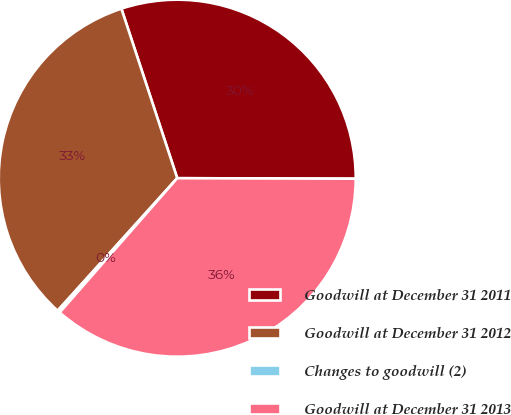Convert chart to OTSL. <chart><loc_0><loc_0><loc_500><loc_500><pie_chart><fcel>Goodwill at December 31 2011<fcel>Goodwill at December 31 2012<fcel>Changes to goodwill (2)<fcel>Goodwill at December 31 2013<nl><fcel>30.11%<fcel>33.25%<fcel>0.24%<fcel>36.4%<nl></chart> 